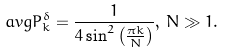<formula> <loc_0><loc_0><loc_500><loc_500>\ a v g { P ^ { \delta } _ { k } } = \frac { 1 } { 4 \sin ^ { 2 } \left ( \frac { \pi k } { N } \right ) } , \, N \gg 1 .</formula> 